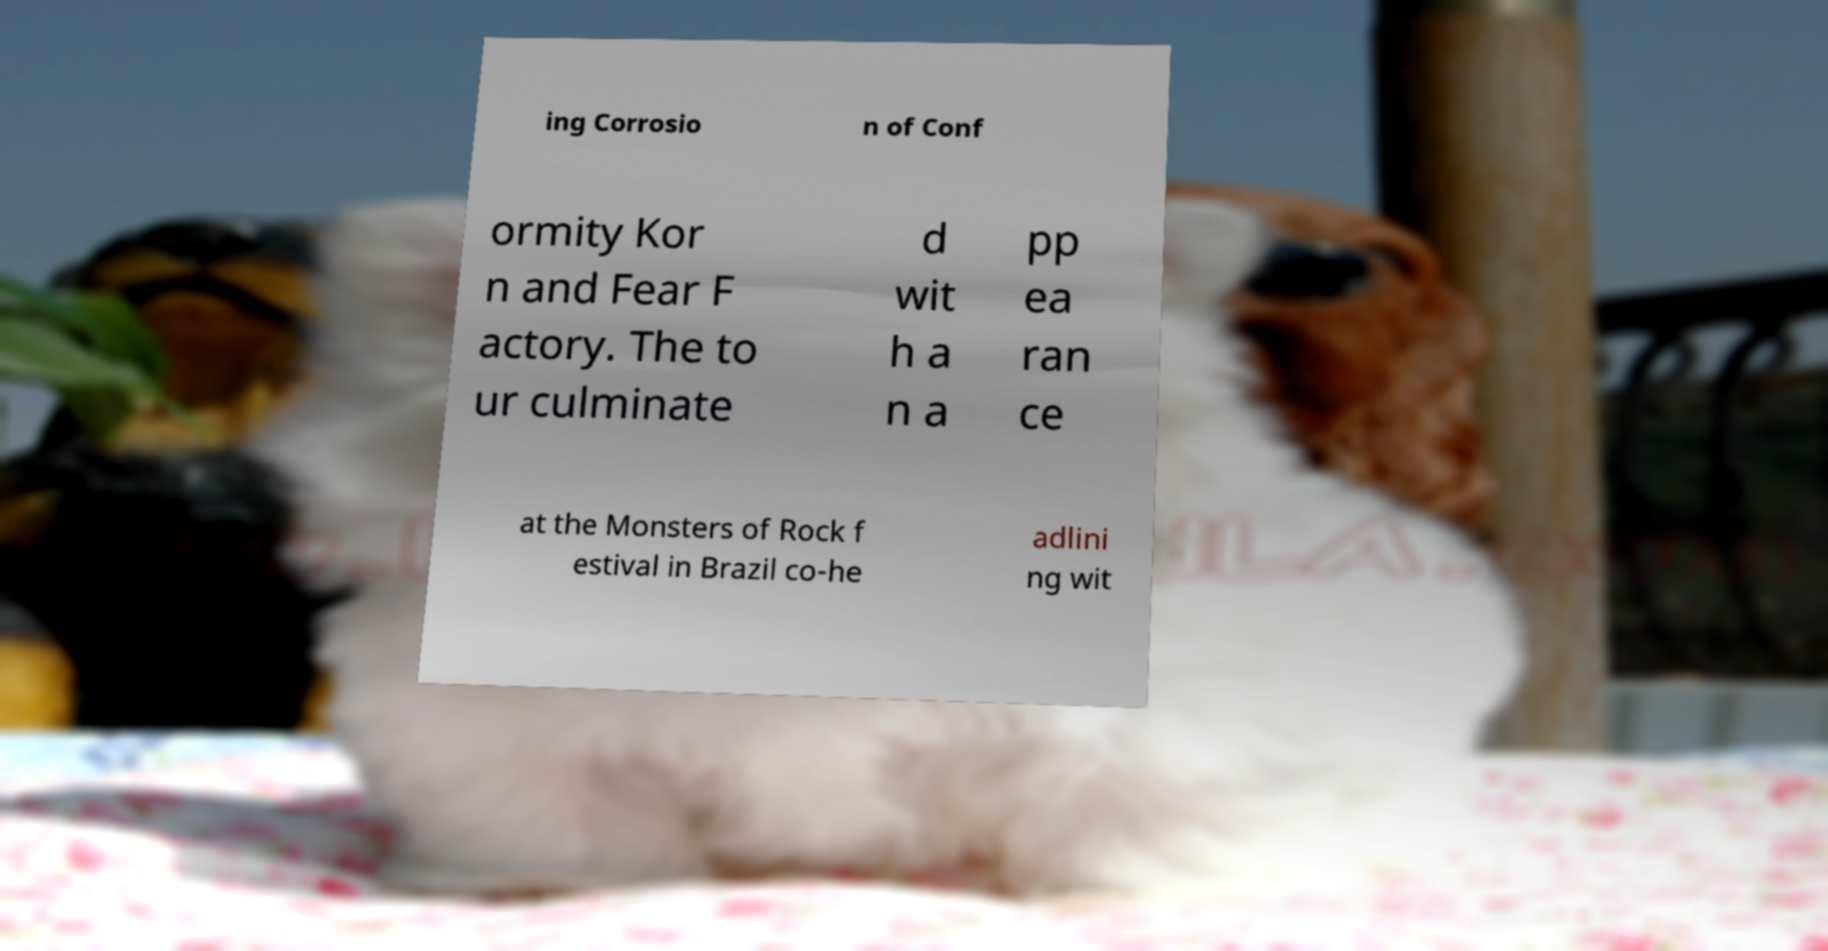Could you assist in decoding the text presented in this image and type it out clearly? ing Corrosio n of Conf ormity Kor n and Fear F actory. The to ur culminate d wit h a n a pp ea ran ce at the Monsters of Rock f estival in Brazil co-he adlini ng wit 